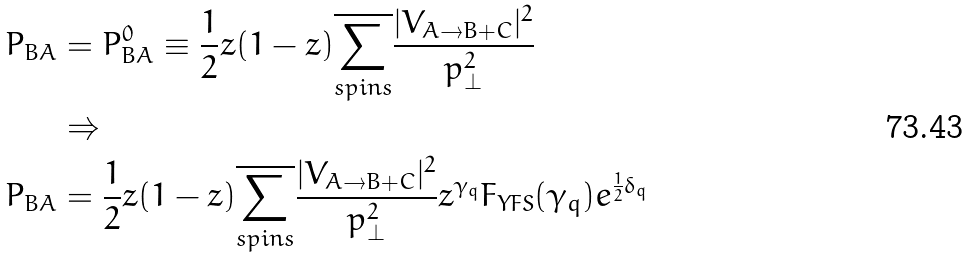<formula> <loc_0><loc_0><loc_500><loc_500>P _ { B A } & = P _ { B A } ^ { 0 } \equiv \frac { 1 } { 2 } z ( 1 - z ) \overline { \underset { s p i n s } { \sum } } \frac { | V _ { A \rightarrow B + C } | ^ { 2 } } { p _ { \perp } ^ { 2 } } \\ & \Rightarrow \\ P _ { B A } & = \frac { 1 } { 2 } z ( 1 - z ) \overline { \underset { s p i n s } { \sum } } \frac { | V _ { A \rightarrow B + C } | ^ { 2 } } { p _ { \perp } ^ { 2 } } z ^ { \gamma _ { q } } F _ { Y F S } ( \gamma _ { q } ) e ^ { \frac { 1 } { 2 } \delta _ { q } }</formula> 